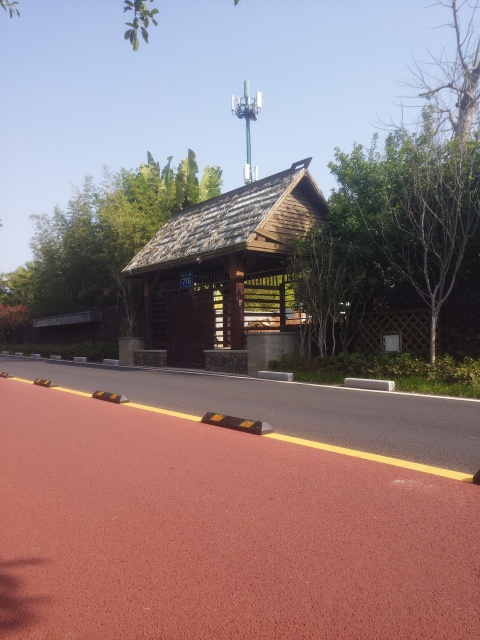What time of day does this photo seem to be taken? Given the brightness of the surroundings and the length of the shadows, it appears to have been taken in the mid to late morning when the sun is relatively high in the sky. 